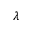Convert formula to latex. <formula><loc_0><loc_0><loc_500><loc_500>\lambda</formula> 